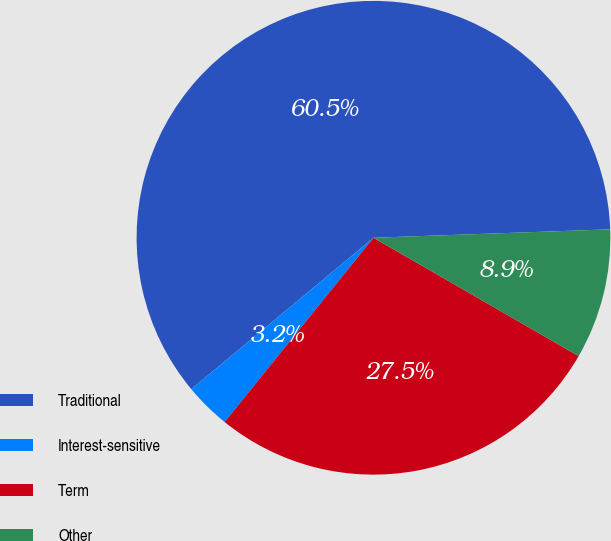<chart> <loc_0><loc_0><loc_500><loc_500><pie_chart><fcel>Traditional<fcel>Interest-sensitive<fcel>Term<fcel>Other<nl><fcel>60.47%<fcel>3.15%<fcel>27.49%<fcel>8.89%<nl></chart> 